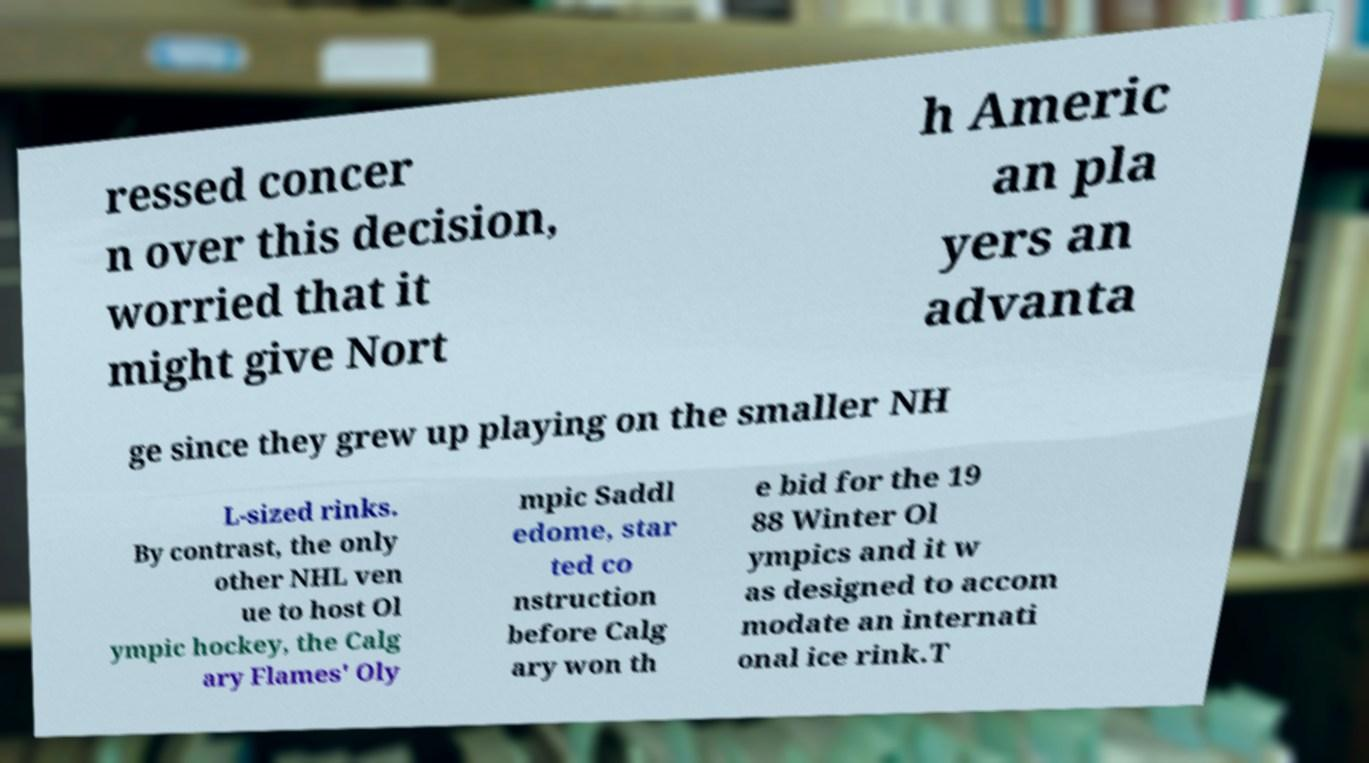Please identify and transcribe the text found in this image. ressed concer n over this decision, worried that it might give Nort h Americ an pla yers an advanta ge since they grew up playing on the smaller NH L-sized rinks. By contrast, the only other NHL ven ue to host Ol ympic hockey, the Calg ary Flames' Oly mpic Saddl edome, star ted co nstruction before Calg ary won th e bid for the 19 88 Winter Ol ympics and it w as designed to accom modate an internati onal ice rink.T 